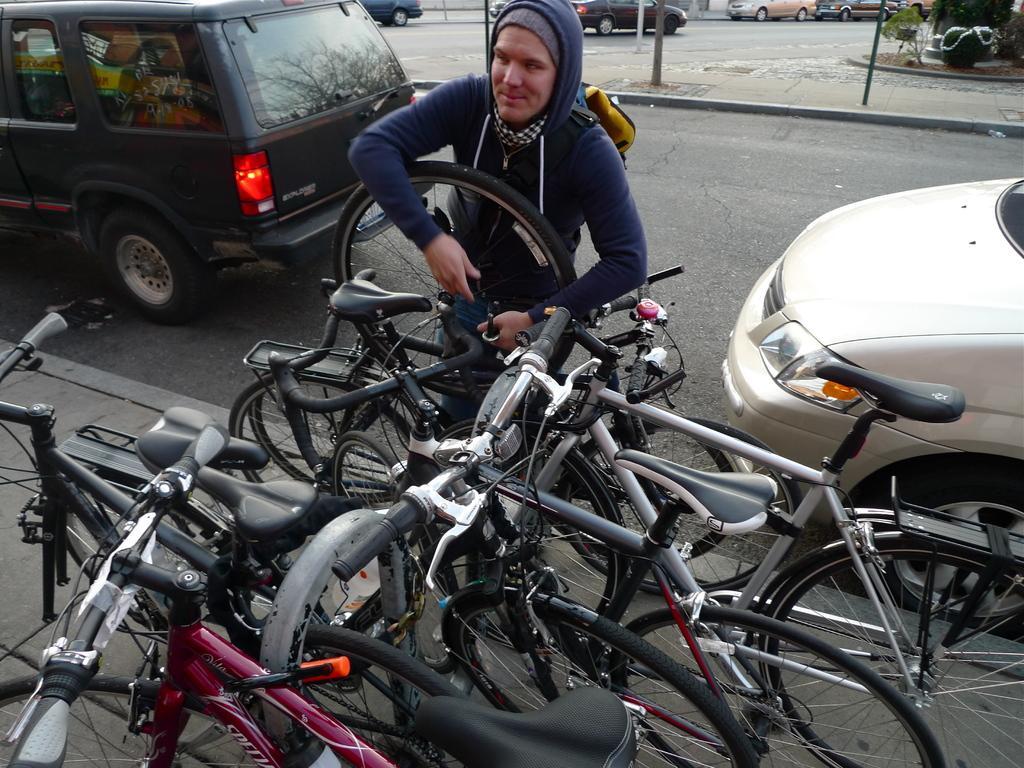Can you describe this image briefly? There are cars on the road. Here we can see bicycles, poles, plants, and a person. 